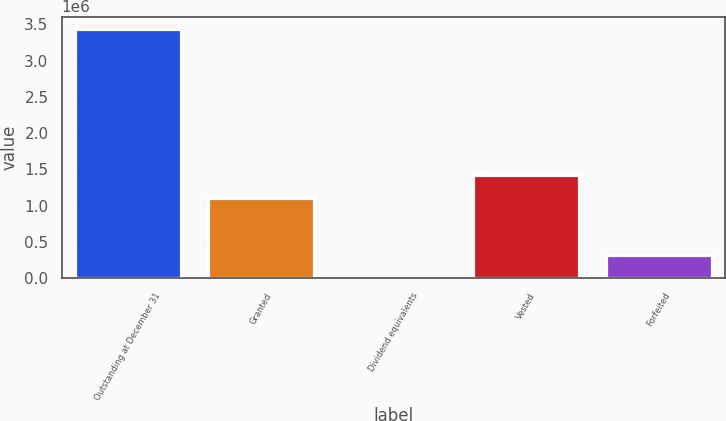<chart> <loc_0><loc_0><loc_500><loc_500><bar_chart><fcel>Outstanding at December 31<fcel>Granted<fcel>Dividend equivalents<fcel>Vested<fcel>Forfeited<nl><fcel>3.43581e+06<fcel>1.10825e+06<fcel>8692<fcel>1.42052e+06<fcel>320963<nl></chart> 